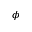Convert formula to latex. <formula><loc_0><loc_0><loc_500><loc_500>\phi</formula> 